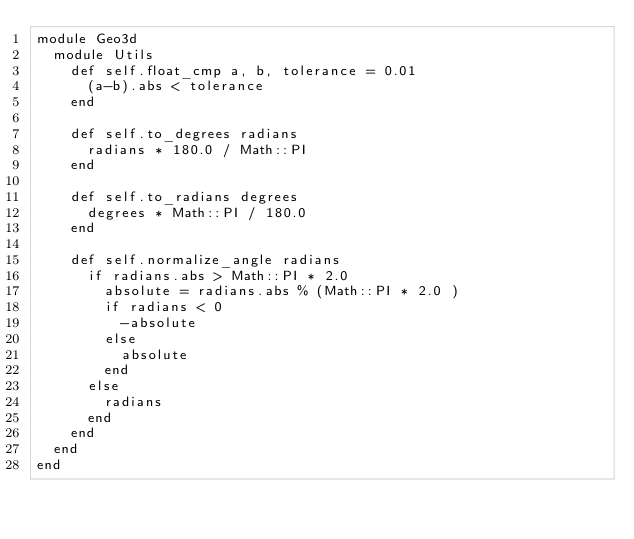<code> <loc_0><loc_0><loc_500><loc_500><_Ruby_>module Geo3d
  module Utils
    def self.float_cmp a, b, tolerance = 0.01
      (a-b).abs < tolerance
    end

    def self.to_degrees radians
      radians * 180.0 / Math::PI
    end

    def self.to_radians degrees
      degrees * Math::PI / 180.0
    end

    def self.normalize_angle radians
      if radians.abs > Math::PI * 2.0
        absolute = radians.abs % (Math::PI * 2.0 )
        if radians < 0
          -absolute
        else
          absolute
        end
      else
        radians
      end
    end
  end
end</code> 